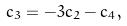Convert formula to latex. <formula><loc_0><loc_0><loc_500><loc_500>c _ { 3 } = - 3 c _ { 2 } - c _ { 4 } ,</formula> 